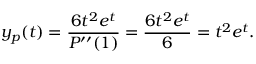<formula> <loc_0><loc_0><loc_500><loc_500>y _ { p } ( t ) = { \frac { 6 t ^ { 2 } e ^ { t } } { P ^ { \prime \prime } ( 1 ) } } = { \frac { 6 t ^ { 2 } e ^ { t } } { 6 } } = t ^ { 2 } e ^ { t } .</formula> 